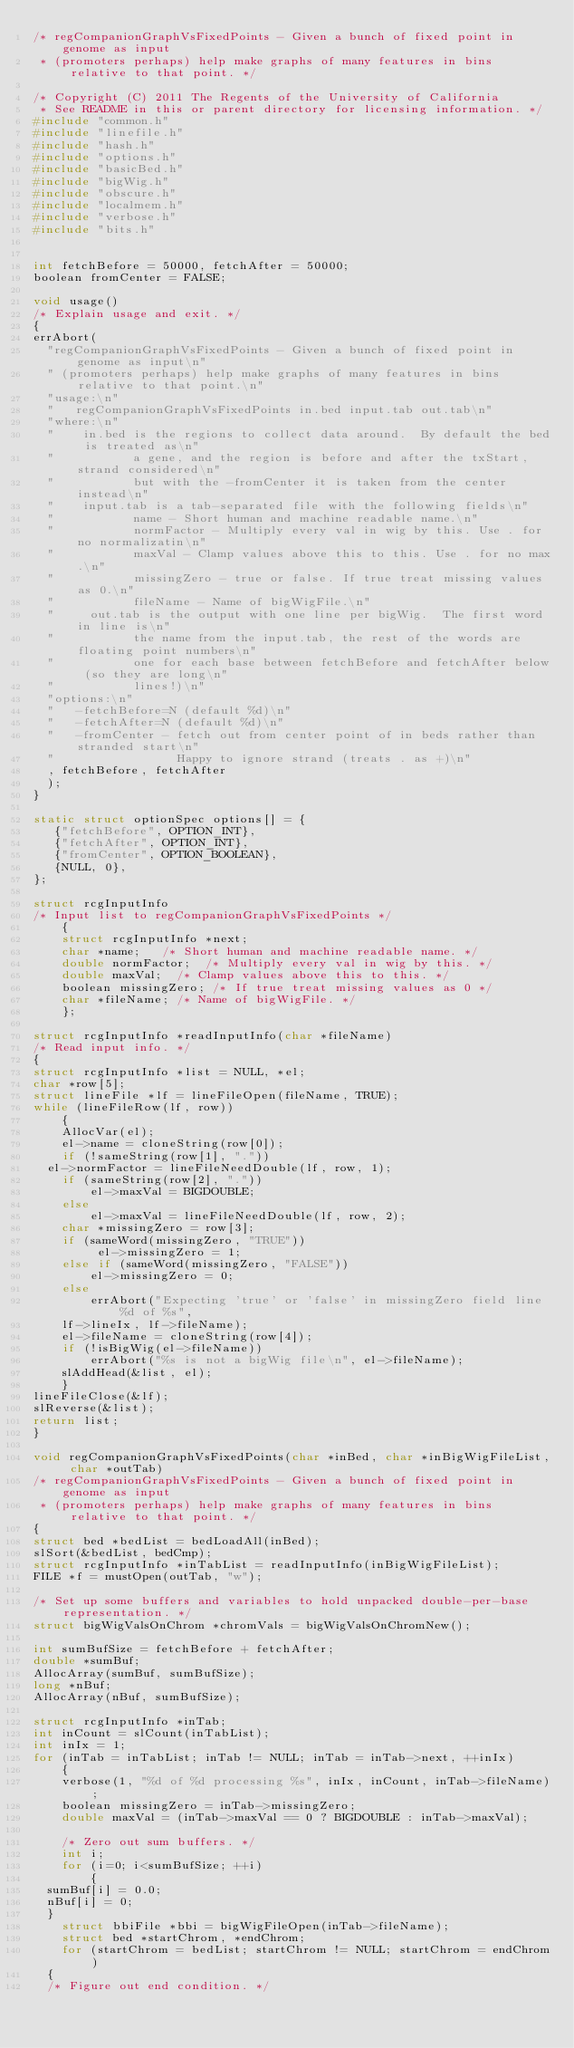<code> <loc_0><loc_0><loc_500><loc_500><_C_>/* regCompanionGraphVsFixedPoints - Given a bunch of fixed point in genome as input 
 * (promoters perhaps) help make graphs of many features in bins relative to that point. */

/* Copyright (C) 2011 The Regents of the University of California 
 * See README in this or parent directory for licensing information. */
#include "common.h"
#include "linefile.h"
#include "hash.h"
#include "options.h"
#include "basicBed.h"
#include "bigWig.h"
#include "obscure.h"
#include "localmem.h"
#include "verbose.h"
#include "bits.h"


int fetchBefore = 50000, fetchAfter = 50000;
boolean fromCenter = FALSE;

void usage()
/* Explain usage and exit. */
{
errAbort(
  "regCompanionGraphVsFixedPoints - Given a bunch of fixed point in genome as input\n"
  " (promoters perhaps) help make graphs of many features in bins relative to that point.\n"
  "usage:\n"
  "   regCompanionGraphVsFixedPoints in.bed input.tab out.tab\n"
  "where:\n"
  "    in.bed is the regions to collect data around.  By default the bed is treated as\n"
  "           a gene, and the region is before and after the txStart, strand considered\n"
  "           but with the -fromCenter it is taken from the center instead\n"
  "    input.tab is a tab-separated file with the following fields\n"
  "           name - Short human and machine readable name.\n"
  "           normFactor - Multiply every val in wig by this. Use . for no normalizatin\n"
  "           maxVal - Clamp values above this to this. Use . for no max.\n"
  "           missingZero - true or false. If true treat missing values as 0.\n"
  "           fileName - Name of bigWigFile.\n"
  "     out.tab is the output with one line per bigWig.  The first word in line is\n"
  "           the name from the input.tab, the rest of the words are floating point numbers\n"
  "           one for each base between fetchBefore and fetchAfter below (so they are long\n"
  "           lines!)\n"
  "options:\n"
  "   -fetchBefore=N (default %d)\n"
  "   -fetchAfter=N (default %d)\n"
  "   -fromCenter - fetch out from center point of in beds rather than stranded start\n"
  "                 Happy to ignore strand (treats . as +)\n"
  , fetchBefore, fetchAfter
  );
}

static struct optionSpec options[] = {
   {"fetchBefore", OPTION_INT},
   {"fetchAfter", OPTION_INT},
   {"fromCenter", OPTION_BOOLEAN},
   {NULL, 0},
};

struct rcgInputInfo
/* Input list to regCompanionGraphVsFixedPoints */
    {
    struct rcgInputInfo *next;
    char *name;		/* Short human and machine readable name. */
    double normFactor;	/* Multiply every val in wig by this. */
    double maxVal;	/* Clamp values above this to this. */
    boolean missingZero; /* If true treat missing values as 0 */
    char *fileName;	/* Name of bigWigFile. */
    };

struct rcgInputInfo *readInputInfo(char *fileName)
/* Read input info. */
{
struct rcgInputInfo *list = NULL, *el;
char *row[5];
struct lineFile *lf = lineFileOpen(fileName, TRUE);
while (lineFileRow(lf, row))
    {
    AllocVar(el);
    el->name = cloneString(row[0]);
    if (!sameString(row[1], "."))
	el->normFactor = lineFileNeedDouble(lf, row, 1);
    if (sameString(row[2], "."))
        el->maxVal = BIGDOUBLE;
    else
        el->maxVal = lineFileNeedDouble(lf, row, 2);
    char *missingZero = row[3];
    if (sameWord(missingZero, "TRUE"))
         el->missingZero = 1;
    else if (sameWord(missingZero, "FALSE"))
        el->missingZero = 0;
    else
        errAbort("Expecting 'true' or 'false' in missingZero field line %d of %s",
		lf->lineIx, lf->fileName);
    el->fileName = cloneString(row[4]);
    if (!isBigWig(el->fileName))
        errAbort("%s is not a bigWig file\n", el->fileName);
    slAddHead(&list, el);
    }
lineFileClose(&lf);
slReverse(&list);
return list;
}

void regCompanionGraphVsFixedPoints(char *inBed, char *inBigWigFileList, char *outTab)
/* regCompanionGraphVsFixedPoints - Given a bunch of fixed point in genome as input 
 * (promoters perhaps) help make graphs of many features in bins relative to that point. */
{
struct bed *bedList = bedLoadAll(inBed);
slSort(&bedList, bedCmp);
struct rcgInputInfo *inTabList = readInputInfo(inBigWigFileList);
FILE *f = mustOpen(outTab, "w");

/* Set up some buffers and variables to hold unpacked double-per-base representation. */
struct bigWigValsOnChrom *chromVals = bigWigValsOnChromNew();

int sumBufSize = fetchBefore + fetchAfter;
double *sumBuf;
AllocArray(sumBuf, sumBufSize);
long *nBuf;
AllocArray(nBuf, sumBufSize);

struct rcgInputInfo *inTab;
int inCount = slCount(inTabList);
int inIx = 1;
for (inTab = inTabList; inTab != NULL; inTab = inTab->next, ++inIx)
    {
    verbose(1, "%d of %d processing %s", inIx, inCount, inTab->fileName);
    boolean missingZero = inTab->missingZero;
    double maxVal = (inTab->maxVal == 0 ? BIGDOUBLE : inTab->maxVal);

    /* Zero out sum buffers. */
    int i;
    for (i=0; i<sumBufSize; ++i)
        {
	sumBuf[i] = 0.0;
	nBuf[i] = 0;
	}
    struct bbiFile *bbi = bigWigFileOpen(inTab->fileName);
    struct bed *startChrom, *endChrom;
    for (startChrom = bedList; startChrom != NULL; startChrom = endChrom)
	{
	/* Figure out end condition. */</code> 